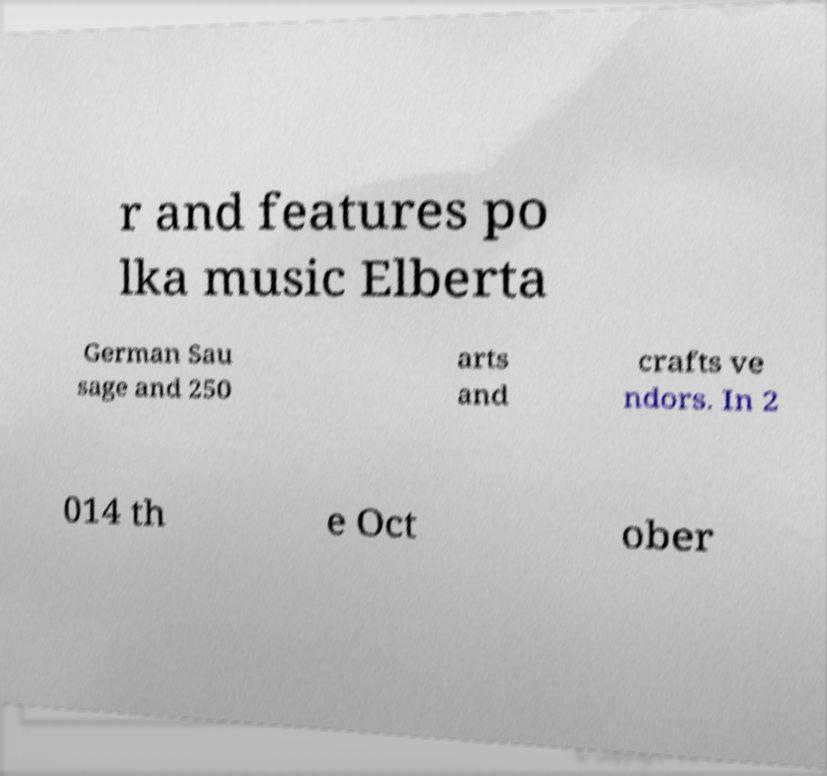I need the written content from this picture converted into text. Can you do that? r and features po lka music Elberta German Sau sage and 250 arts and crafts ve ndors. In 2 014 th e Oct ober 